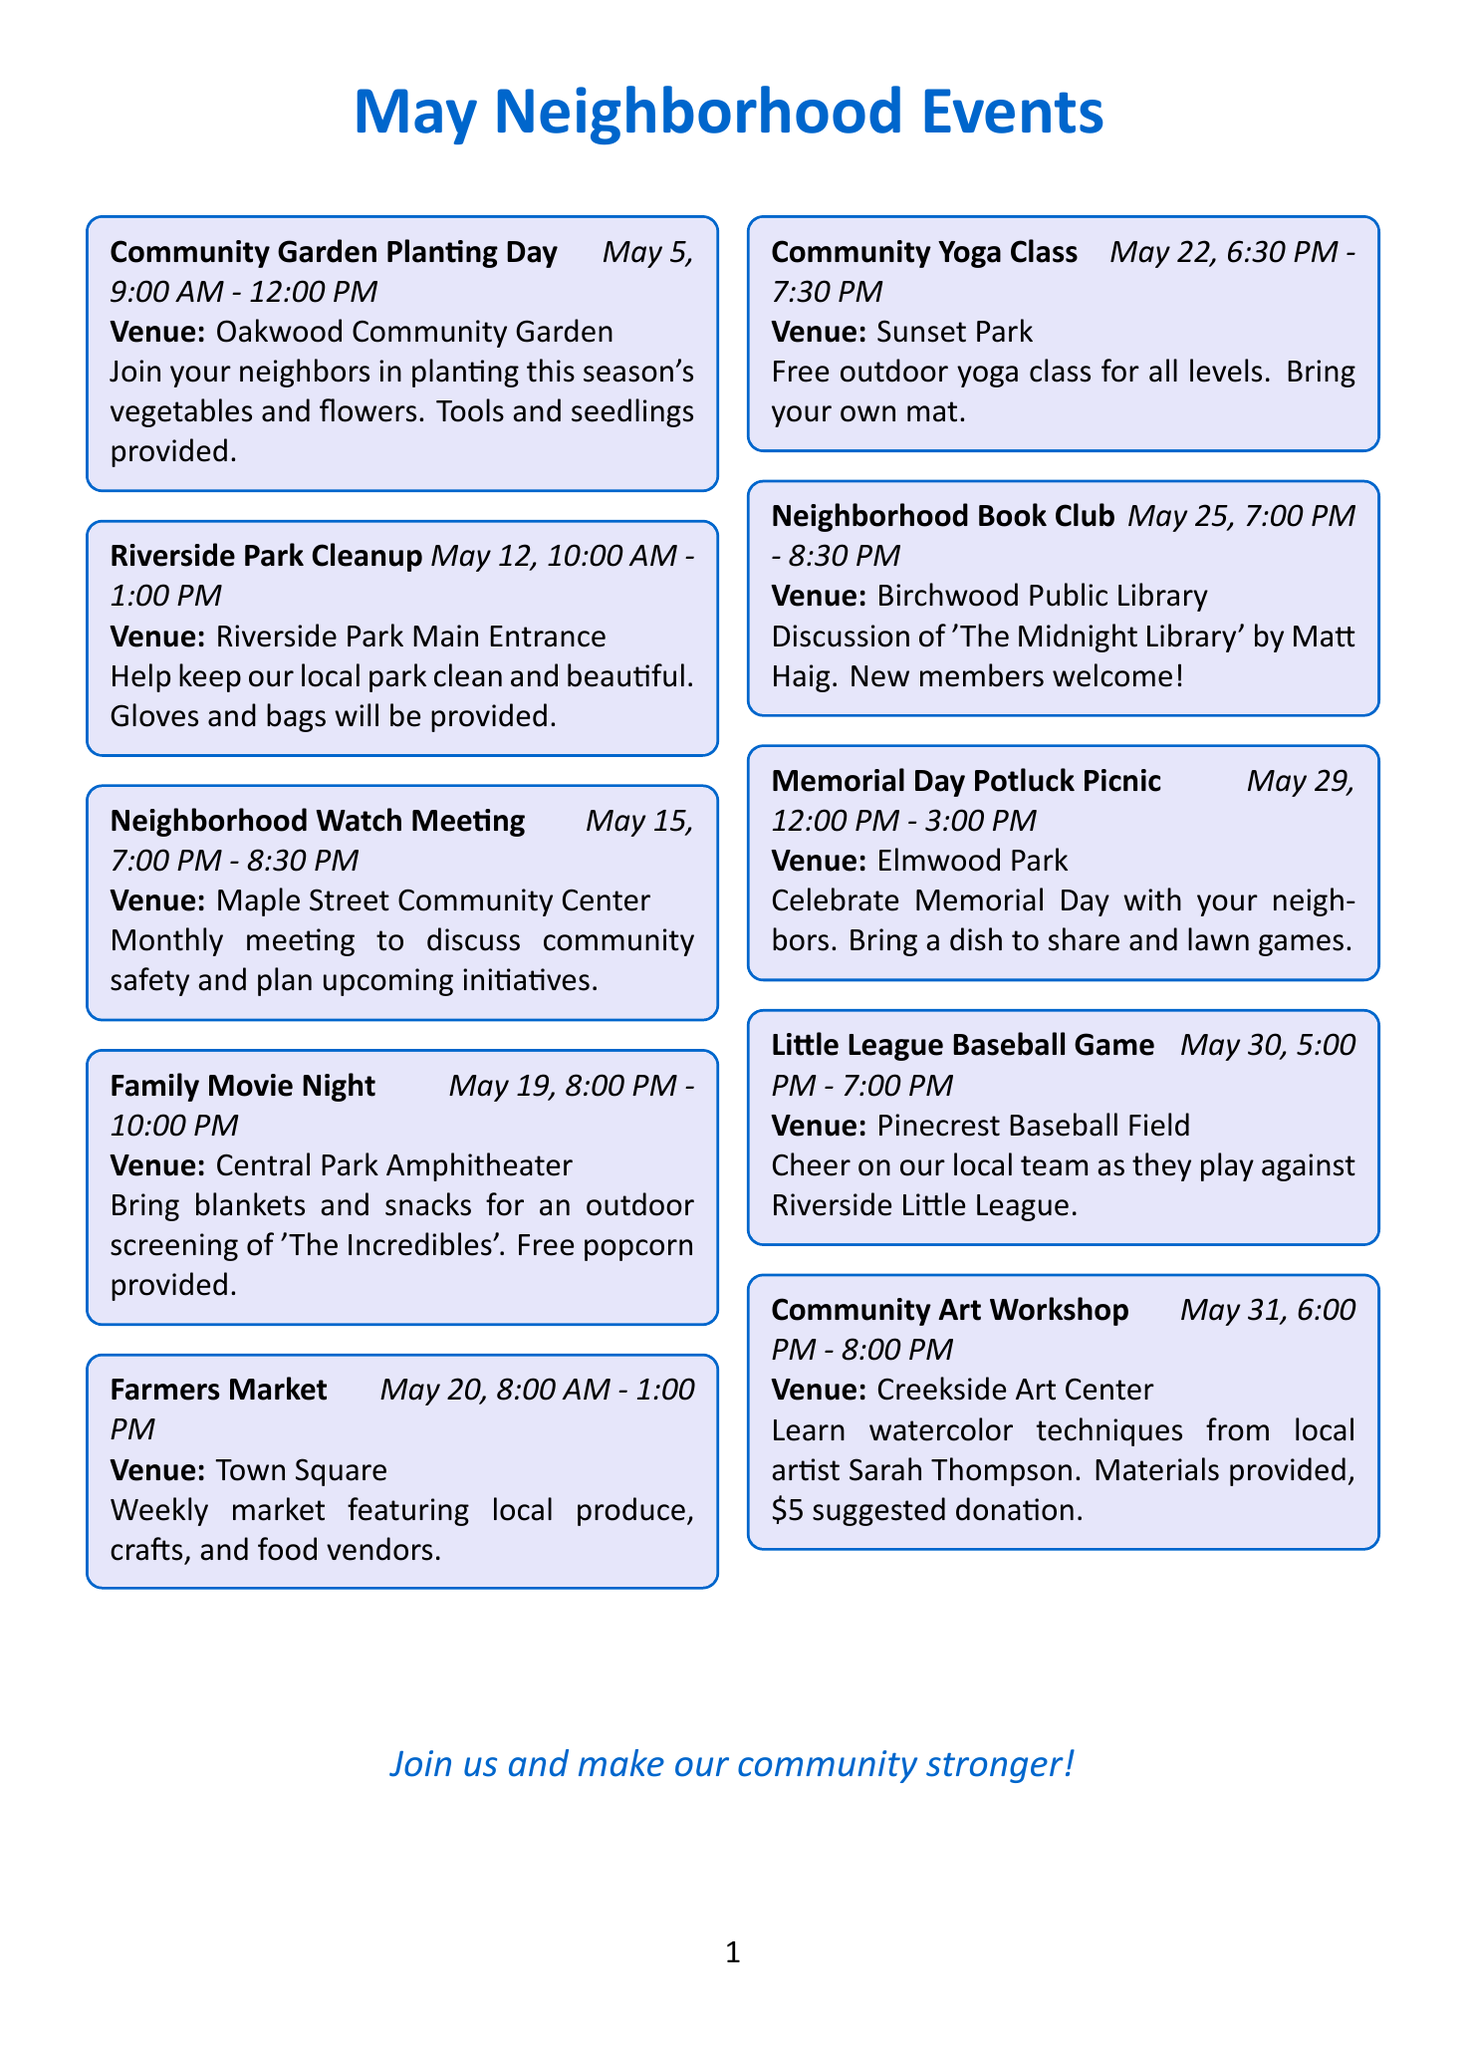What is the date of the Community Garden Planting Day? The document states that the Community Garden Planting Day is scheduled for May 5.
Answer: May 5 What is the venue for the Family Movie Night? The document specifies that the Family Movie Night will take place at Central Park Amphitheater.
Answer: Central Park Amphitheater What time does the Neighborhood Watch Meeting start? The time for the Neighborhood Watch Meeting is listed in the document as 7:00 PM.
Answer: 7:00 PM How long is the Community Yoga Class? The document states that the Community Yoga Class is from 6:30 PM to 7:30 PM, which is one hour long.
Answer: One hour What event occurs just before the Memorial Day Potluck Picnic? The document indicates that the Neighborhood Book Club takes place on May 25, just before the Memorial Day Potluck Picnic on May 29.
Answer: Neighborhood Book Club How many events are scheduled for May 30? The document lists one event on May 30, which is the Little League Baseball Game.
Answer: One event Which event requires a donation? The Community Art Workshop in the document mentions a suggested donation of $5.
Answer: Community Art Workshop What is the main theme of the Riverside Park Cleanup? The document describes the Riverside Park Cleanup as an event to help keep the local park clean and beautiful.
Answer: Clean and beautiful How many events are occurring on May 20? The document states that there is one event scheduled for May 20, which is the Farmers Market.
Answer: One event 